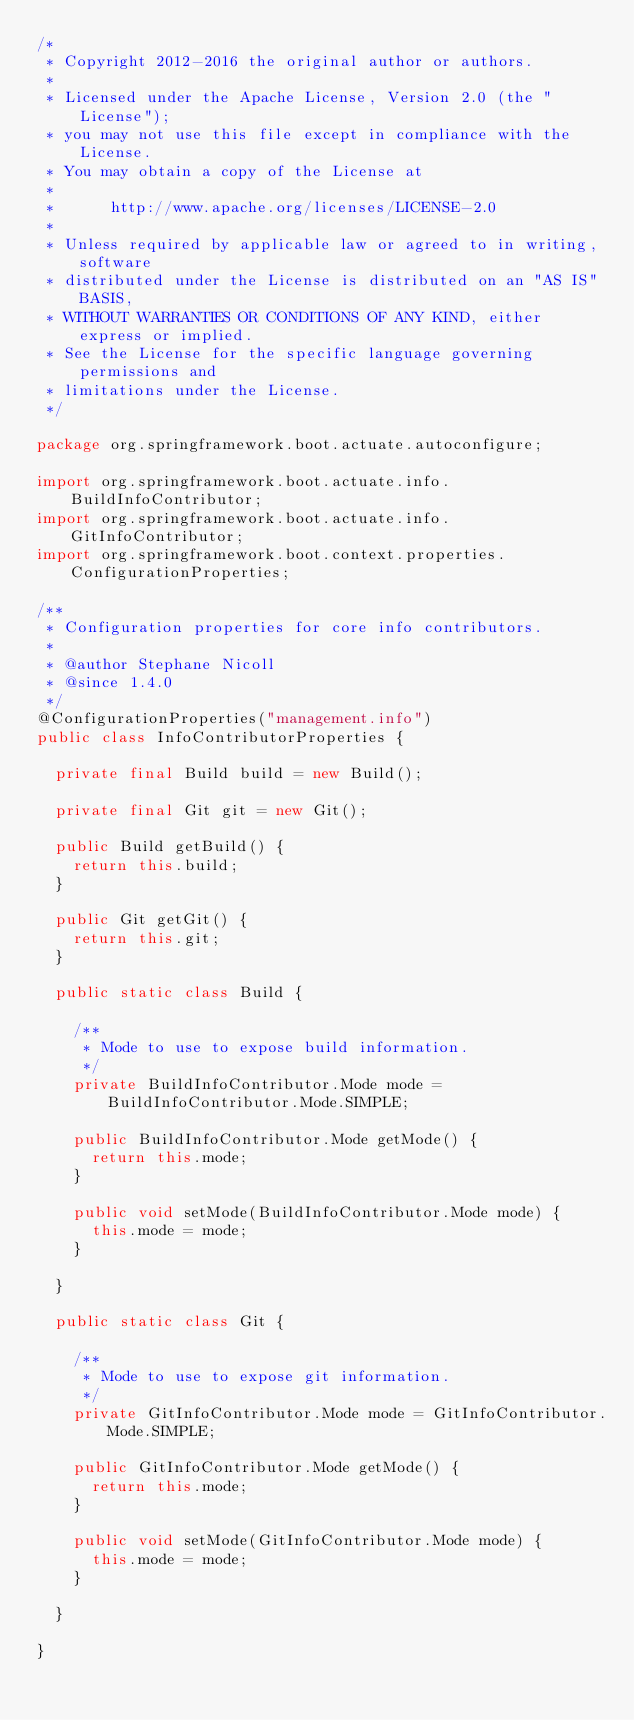Convert code to text. <code><loc_0><loc_0><loc_500><loc_500><_Java_>/*
 * Copyright 2012-2016 the original author or authors.
 *
 * Licensed under the Apache License, Version 2.0 (the "License");
 * you may not use this file except in compliance with the License.
 * You may obtain a copy of the License at
 *
 *      http://www.apache.org/licenses/LICENSE-2.0
 *
 * Unless required by applicable law or agreed to in writing, software
 * distributed under the License is distributed on an "AS IS" BASIS,
 * WITHOUT WARRANTIES OR CONDITIONS OF ANY KIND, either express or implied.
 * See the License for the specific language governing permissions and
 * limitations under the License.
 */

package org.springframework.boot.actuate.autoconfigure;

import org.springframework.boot.actuate.info.BuildInfoContributor;
import org.springframework.boot.actuate.info.GitInfoContributor;
import org.springframework.boot.context.properties.ConfigurationProperties;

/**
 * Configuration properties for core info contributors.
 *
 * @author Stephane Nicoll
 * @since 1.4.0
 */
@ConfigurationProperties("management.info")
public class InfoContributorProperties {

	private final Build build = new Build();

	private final Git git = new Git();

	public Build getBuild() {
		return this.build;
	}

	public Git getGit() {
		return this.git;
	}

	public static class Build {

		/**
		 * Mode to use to expose build information.
		 */
		private BuildInfoContributor.Mode mode = BuildInfoContributor.Mode.SIMPLE;

		public BuildInfoContributor.Mode getMode() {
			return this.mode;
		}

		public void setMode(BuildInfoContributor.Mode mode) {
			this.mode = mode;
		}

	}

	public static class Git {

		/**
		 * Mode to use to expose git information.
		 */
		private GitInfoContributor.Mode mode = GitInfoContributor.Mode.SIMPLE;

		public GitInfoContributor.Mode getMode() {
			return this.mode;
		}

		public void setMode(GitInfoContributor.Mode mode) {
			this.mode = mode;
		}

	}

}
</code> 